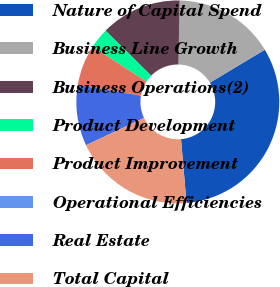<chart> <loc_0><loc_0><loc_500><loc_500><pie_chart><fcel>Nature of Capital Spend<fcel>Business Line Growth<fcel>Business Operations(2)<fcel>Product Development<fcel>Product Improvement<fcel>Operational Efficiencies<fcel>Real Estate<fcel>Total Capital<nl><fcel>32.23%<fcel>16.12%<fcel>12.9%<fcel>3.24%<fcel>6.46%<fcel>0.02%<fcel>9.68%<fcel>19.35%<nl></chart> 